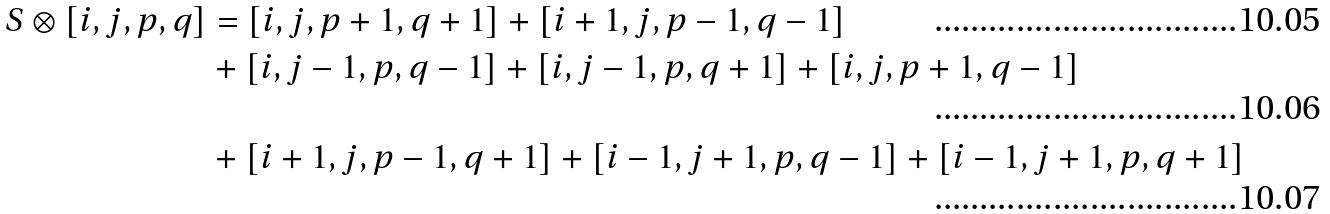Convert formula to latex. <formula><loc_0><loc_0><loc_500><loc_500>S \otimes [ i , j , p , q ] & = [ i , j , p + 1 , q + 1 ] + [ i + 1 , j , p - 1 , q - 1 ] \\ & + [ i , j - 1 , p , q - 1 ] + [ i , j - 1 , p , q + 1 ] + [ i , j , p + 1 , q - 1 ] \\ & + [ i + 1 , j , p - 1 , q + 1 ] + [ i - 1 , j + 1 , p , q - 1 ] + [ i - 1 , j + 1 , p , q + 1 ]</formula> 